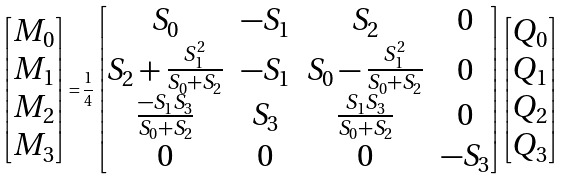<formula> <loc_0><loc_0><loc_500><loc_500>\begin{bmatrix} M _ { 0 } \\ M _ { 1 } \\ M _ { 2 } \\ M _ { 3 } \end{bmatrix} = \frac { 1 } { 4 } \begin{bmatrix} S _ { 0 } & - S _ { 1 } & S _ { 2 } & 0 \\ S _ { 2 } + \frac { S _ { 1 } ^ { 2 } } { S _ { 0 } + S _ { 2 } } & - S _ { 1 } & S _ { 0 } - \frac { S _ { 1 } ^ { 2 } } { S _ { 0 } + S _ { 2 } } & 0 \\ \frac { - S _ { 1 } S _ { 3 } } { S _ { 0 } + S _ { 2 } } & S _ { 3 } & \frac { S _ { 1 } S _ { 3 } } { S _ { 0 } + S _ { 2 } } & 0 \\ 0 & 0 & 0 & - S _ { 3 } \end{bmatrix} \begin{bmatrix} Q _ { 0 } \\ Q _ { 1 } \\ Q _ { 2 } \\ Q _ { 3 } \end{bmatrix}</formula> 